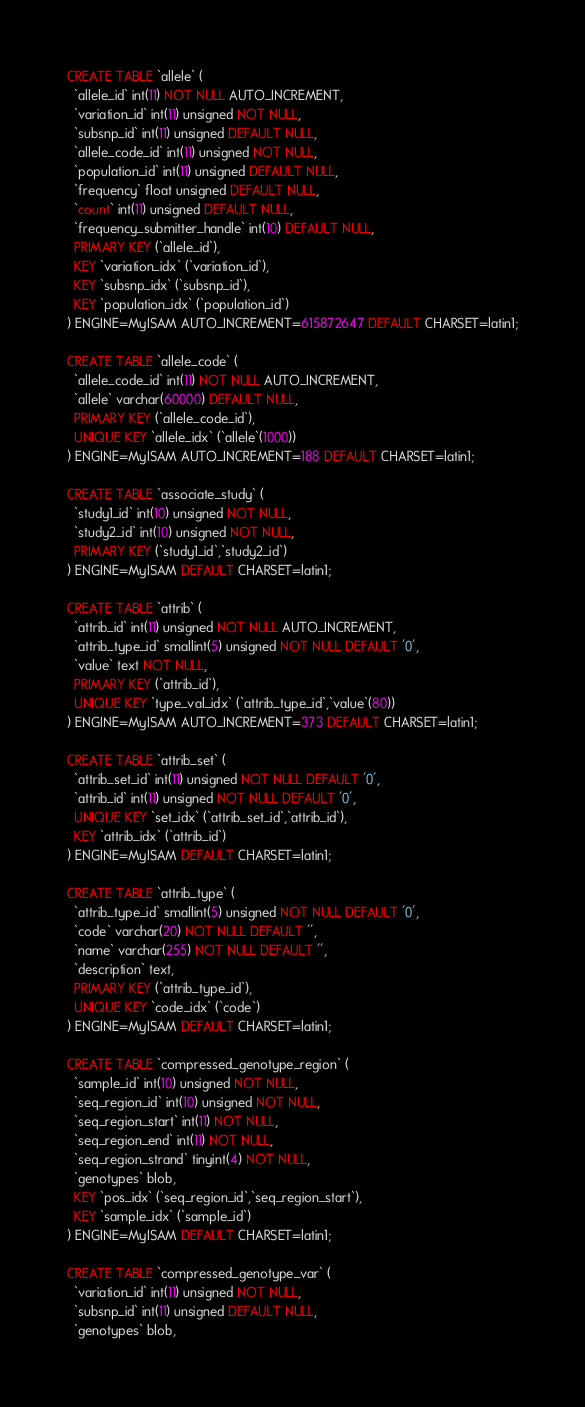Convert code to text. <code><loc_0><loc_0><loc_500><loc_500><_SQL_>CREATE TABLE `allele` (
  `allele_id` int(11) NOT NULL AUTO_INCREMENT,
  `variation_id` int(11) unsigned NOT NULL,
  `subsnp_id` int(11) unsigned DEFAULT NULL,
  `allele_code_id` int(11) unsigned NOT NULL,
  `population_id` int(11) unsigned DEFAULT NULL,
  `frequency` float unsigned DEFAULT NULL,
  `count` int(11) unsigned DEFAULT NULL,
  `frequency_submitter_handle` int(10) DEFAULT NULL,
  PRIMARY KEY (`allele_id`),
  KEY `variation_idx` (`variation_id`),
  KEY `subsnp_idx` (`subsnp_id`),
  KEY `population_idx` (`population_id`)
) ENGINE=MyISAM AUTO_INCREMENT=615872647 DEFAULT CHARSET=latin1;

CREATE TABLE `allele_code` (
  `allele_code_id` int(11) NOT NULL AUTO_INCREMENT,
  `allele` varchar(60000) DEFAULT NULL,
  PRIMARY KEY (`allele_code_id`),
  UNIQUE KEY `allele_idx` (`allele`(1000))
) ENGINE=MyISAM AUTO_INCREMENT=188 DEFAULT CHARSET=latin1;

CREATE TABLE `associate_study` (
  `study1_id` int(10) unsigned NOT NULL,
  `study2_id` int(10) unsigned NOT NULL,
  PRIMARY KEY (`study1_id`,`study2_id`)
) ENGINE=MyISAM DEFAULT CHARSET=latin1;

CREATE TABLE `attrib` (
  `attrib_id` int(11) unsigned NOT NULL AUTO_INCREMENT,
  `attrib_type_id` smallint(5) unsigned NOT NULL DEFAULT '0',
  `value` text NOT NULL,
  PRIMARY KEY (`attrib_id`),
  UNIQUE KEY `type_val_idx` (`attrib_type_id`,`value`(80))
) ENGINE=MyISAM AUTO_INCREMENT=373 DEFAULT CHARSET=latin1;

CREATE TABLE `attrib_set` (
  `attrib_set_id` int(11) unsigned NOT NULL DEFAULT '0',
  `attrib_id` int(11) unsigned NOT NULL DEFAULT '0',
  UNIQUE KEY `set_idx` (`attrib_set_id`,`attrib_id`),
  KEY `attrib_idx` (`attrib_id`)
) ENGINE=MyISAM DEFAULT CHARSET=latin1;

CREATE TABLE `attrib_type` (
  `attrib_type_id` smallint(5) unsigned NOT NULL DEFAULT '0',
  `code` varchar(20) NOT NULL DEFAULT '',
  `name` varchar(255) NOT NULL DEFAULT '',
  `description` text,
  PRIMARY KEY (`attrib_type_id`),
  UNIQUE KEY `code_idx` (`code`)
) ENGINE=MyISAM DEFAULT CHARSET=latin1;

CREATE TABLE `compressed_genotype_region` (
  `sample_id` int(10) unsigned NOT NULL,
  `seq_region_id` int(10) unsigned NOT NULL,
  `seq_region_start` int(11) NOT NULL,
  `seq_region_end` int(11) NOT NULL,
  `seq_region_strand` tinyint(4) NOT NULL,
  `genotypes` blob,
  KEY `pos_idx` (`seq_region_id`,`seq_region_start`),
  KEY `sample_idx` (`sample_id`)
) ENGINE=MyISAM DEFAULT CHARSET=latin1;

CREATE TABLE `compressed_genotype_var` (
  `variation_id` int(11) unsigned NOT NULL,
  `subsnp_id` int(11) unsigned DEFAULT NULL,
  `genotypes` blob,</code> 